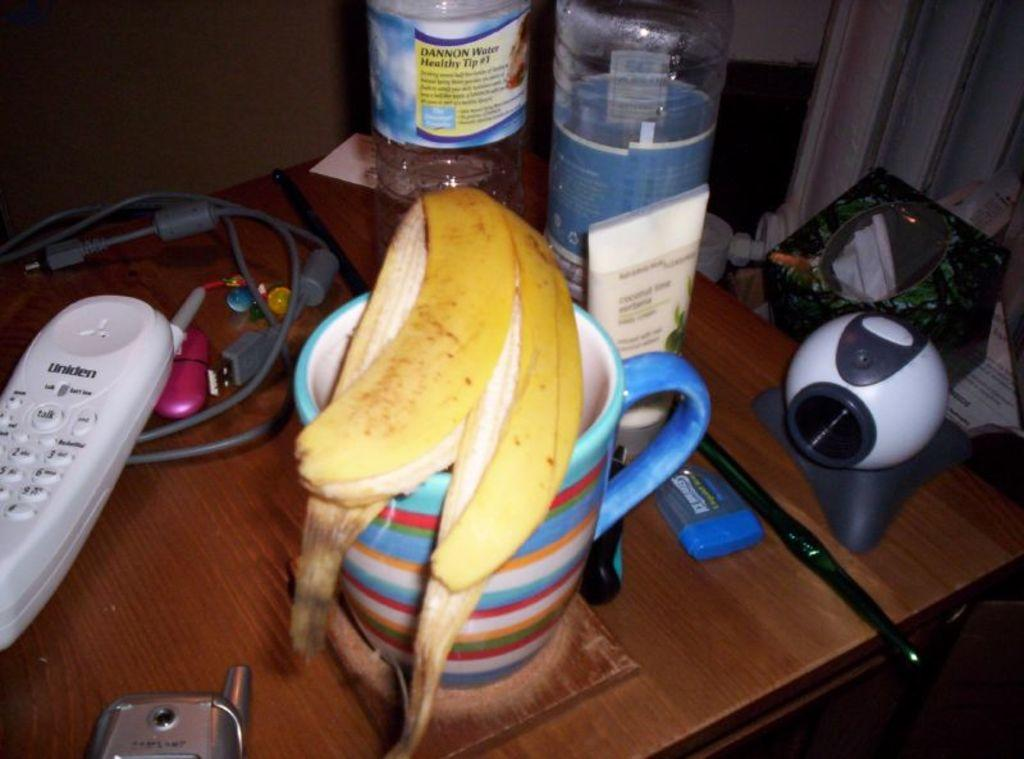<image>
Relay a brief, clear account of the picture shown. A banana peel is on a coffee cup and next to a Uniden phone. 